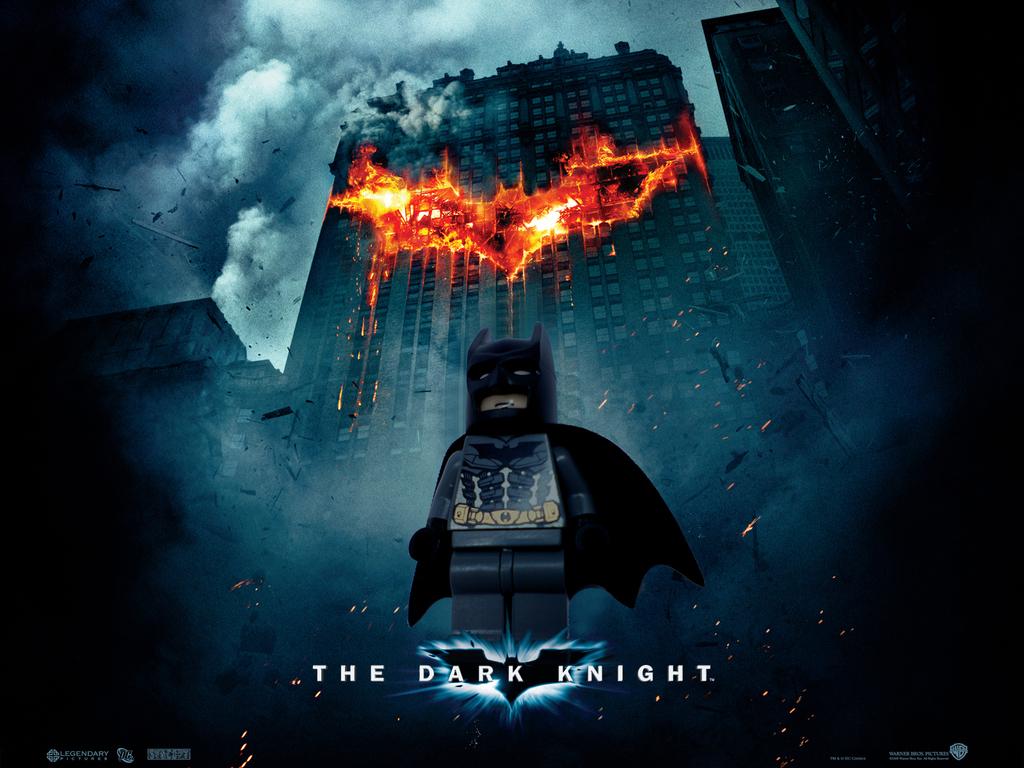Who is that?
Your answer should be very brief. The dark knight. 